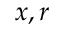Convert formula to latex. <formula><loc_0><loc_0><loc_500><loc_500>x , r</formula> 